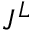Convert formula to latex. <formula><loc_0><loc_0><loc_500><loc_500>J ^ { L }</formula> 